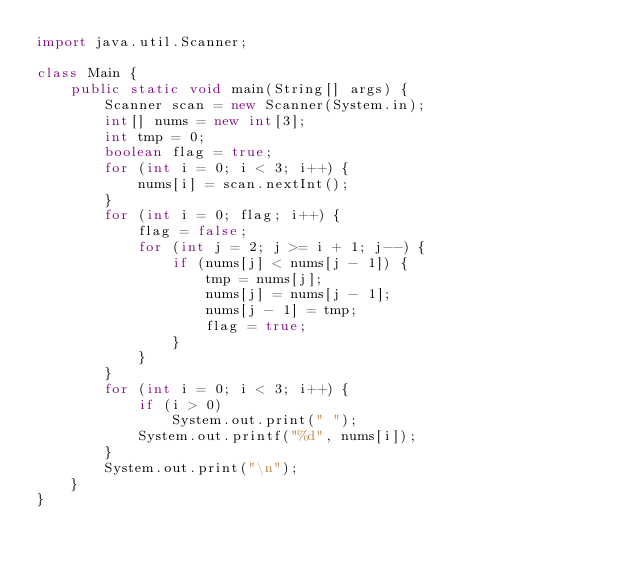Convert code to text. <code><loc_0><loc_0><loc_500><loc_500><_Java_>import java.util.Scanner;

class Main {
    public static void main(String[] args) {
        Scanner scan = new Scanner(System.in);
        int[] nums = new int[3];
        int tmp = 0;
        boolean flag = true;
        for (int i = 0; i < 3; i++) {
            nums[i] = scan.nextInt();
        }
        for (int i = 0; flag; i++) {
            flag = false;
            for (int j = 2; j >= i + 1; j--) {
                if (nums[j] < nums[j - 1]) {
                    tmp = nums[j];
                    nums[j] = nums[j - 1];
                    nums[j - 1] = tmp;
                    flag = true;
                }
            }
        }
        for (int i = 0; i < 3; i++) {
            if (i > 0)
                System.out.print(" ");
            System.out.printf("%d", nums[i]);
        }
        System.out.print("\n");
    }
}

</code> 